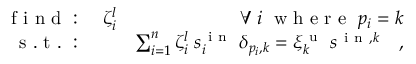<formula> <loc_0><loc_0><loc_500><loc_500>\begin{array} { r l r } { f i n d \colon } & \zeta _ { i } ^ { l } } & { \forall \, i \, w h e r e \, p _ { i } = k } \\ { s . t . \colon } & { \sum _ { i = 1 } ^ { n } \zeta _ { i } ^ { l } \, s _ { i } ^ { i n } \, \delta _ { p _ { i } , k } = \xi _ { k } ^ { u } \, s ^ { i n , k } \quad , } \end{array}</formula> 